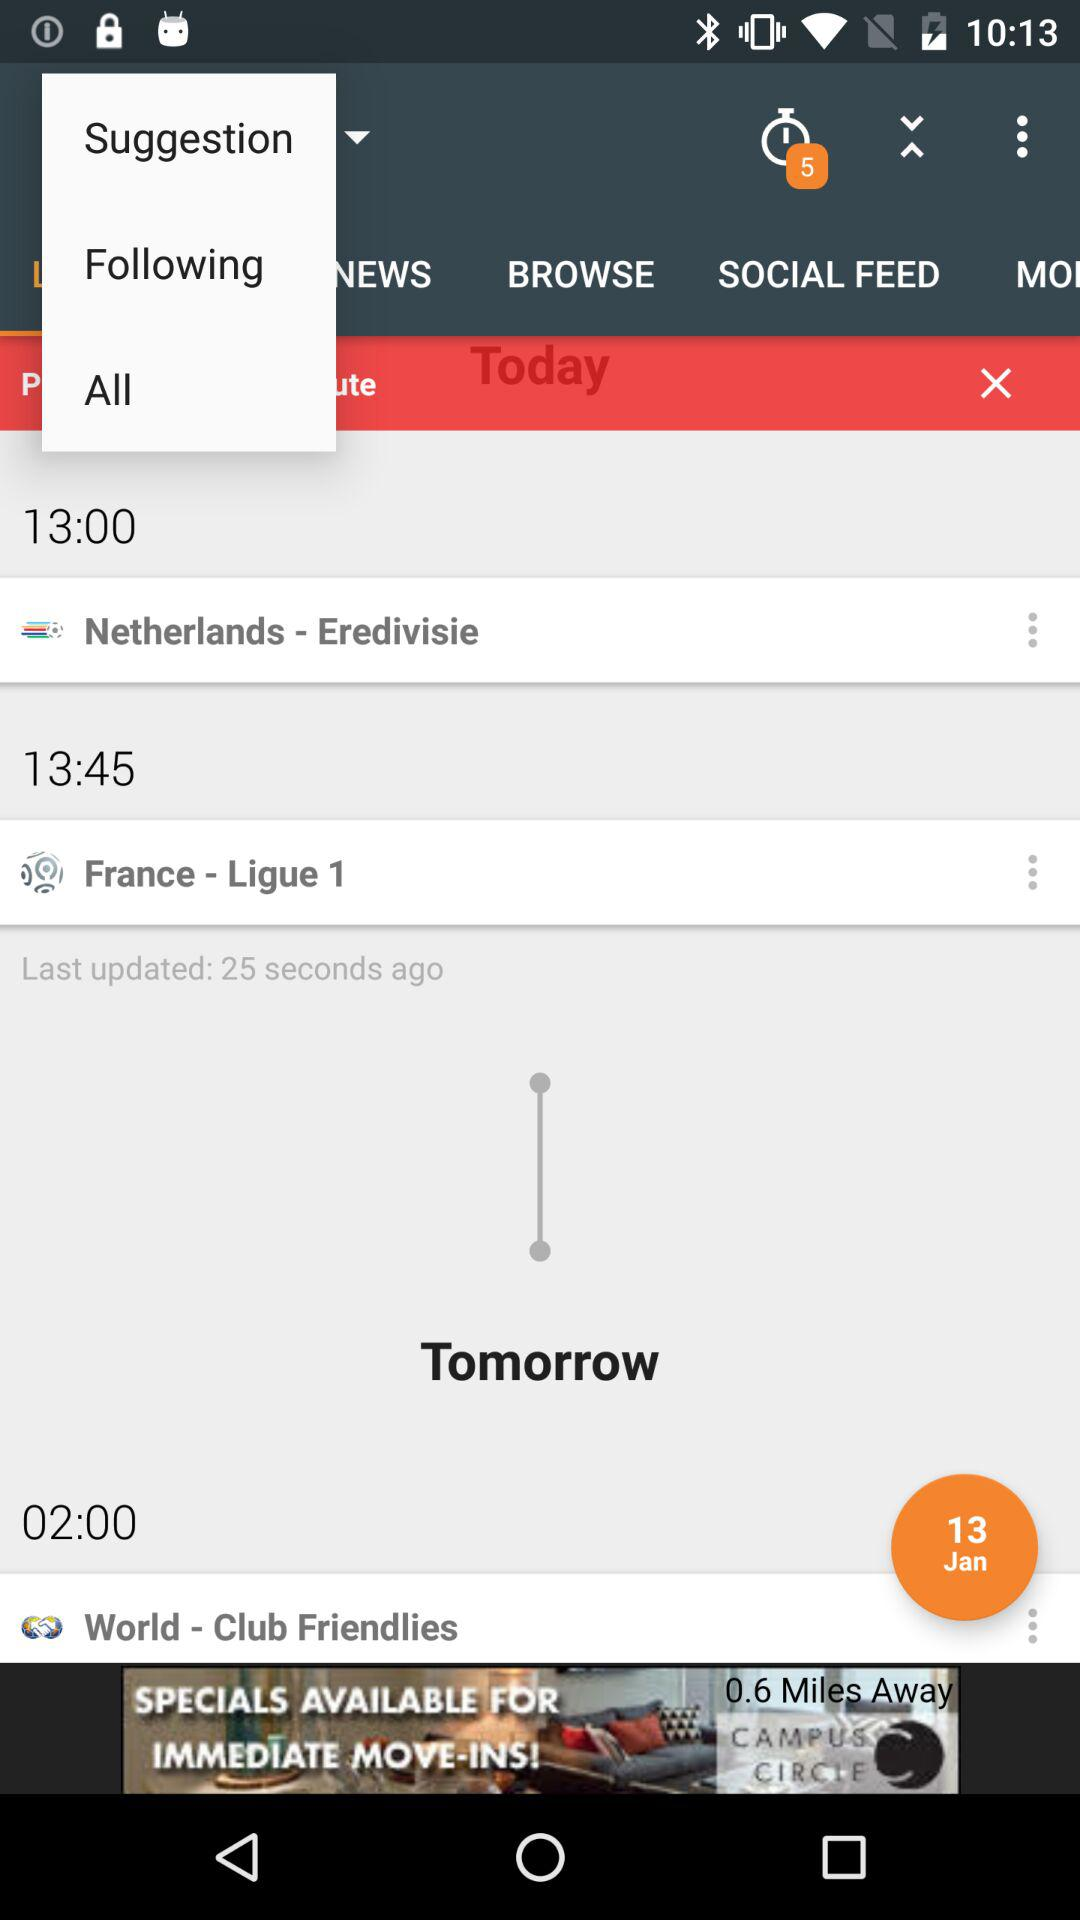What is the location at 02:00?
When the provided information is insufficient, respond with <no answer>. <no answer> 